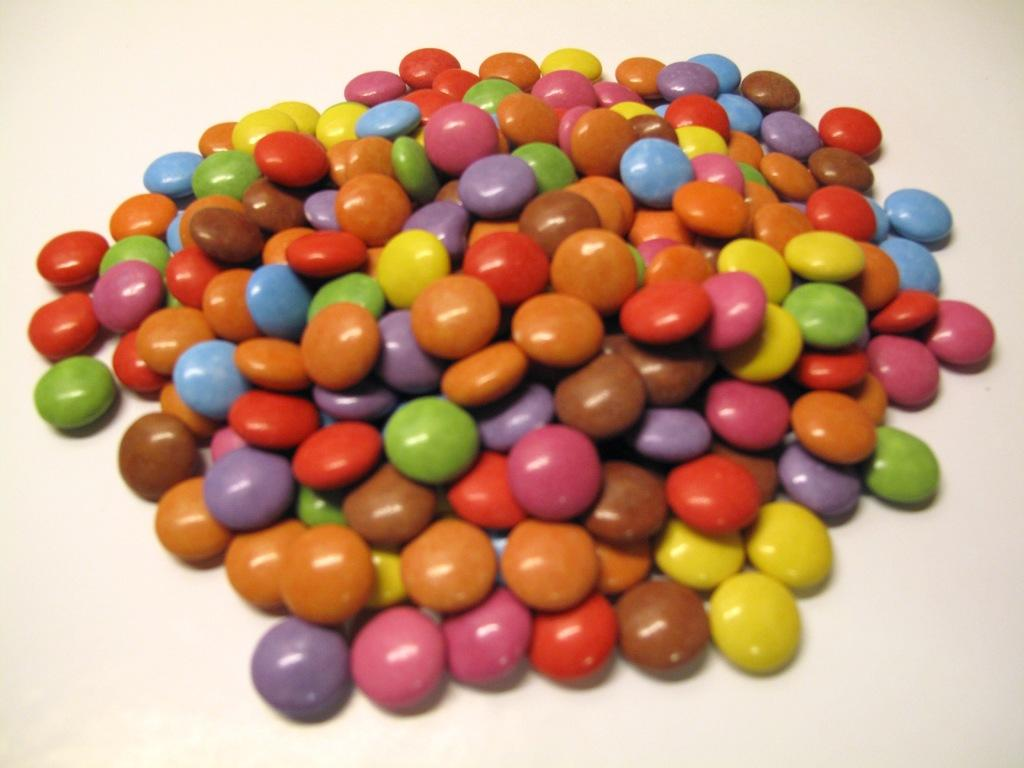What can be observed about the objects in the image? The objects in the image are colorful. Where are the objects located? The objects are on a surface. What is the color of the background in the image? The background of the image is white in color. Can you smell the colorful objects in the image? The sense of smell is not relevant to the image, as it only provides visual information. 